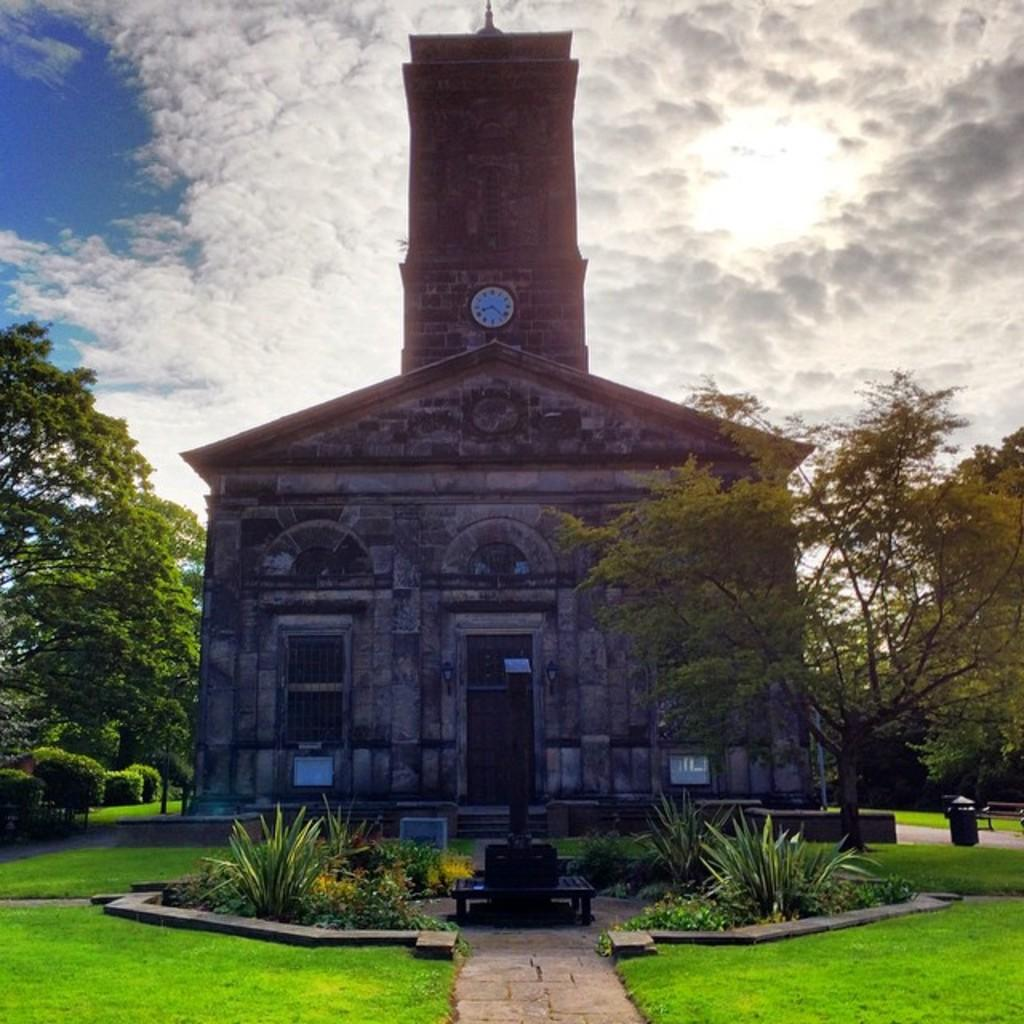What type of vegetation can be seen in the image? There are trees, plants, and grass visible in the image. What type of structure is present in the image? There is a building in the image. What time-telling device is present in the image? There is a clock in the image. What can be seen in the background of the image? There are clouds and the sky visible in the background of the image. What type of acoustics can be heard from the trees in the image? There is no sound or acoustics mentioned or depicted in the image, as it is a still image. Can you see a beetle crawling on the grass in the image? There is no beetle present in the image; it only features trees, plants, grass, a building, a clock, clouds, and the sky. 